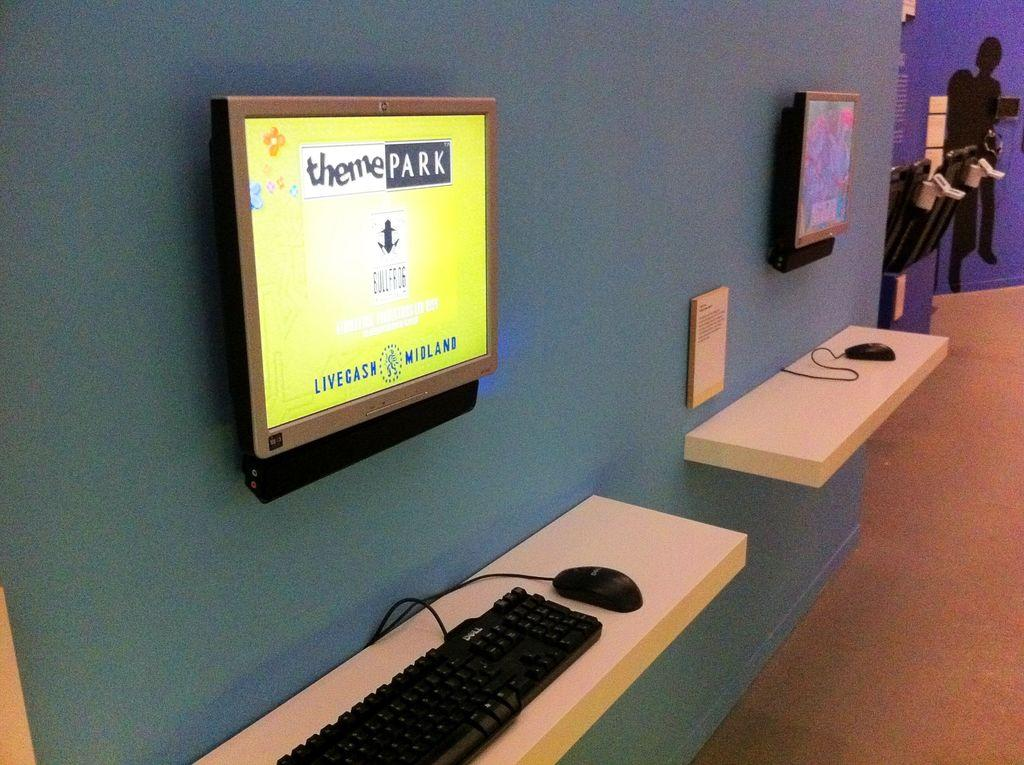Provide a one-sentence caption for the provided image. A wall mounted screen brightly displays some theme park information. 